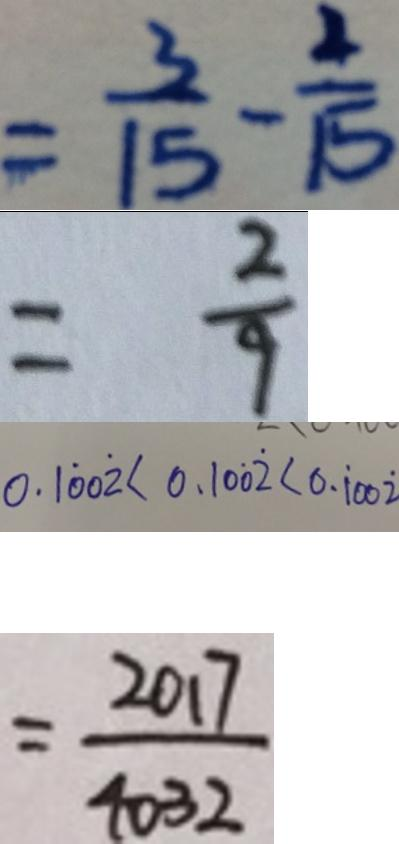Convert formula to latex. <formula><loc_0><loc_0><loc_500><loc_500>= \frac { 3 } { 1 5 } - \frac { 2 } { 1 5 } 
 = \frac { 2 } { 9 } 
 0 . 1 \dot { 0 } 0 \dot { 2 } < 0 . 1 0 \dot { 0 } \dot { 2 } < 0 . \dot { 1 } 0 0 \dot { 2 } 
 = \frac { 2 0 1 7 } { 4 0 3 2 }</formula> 